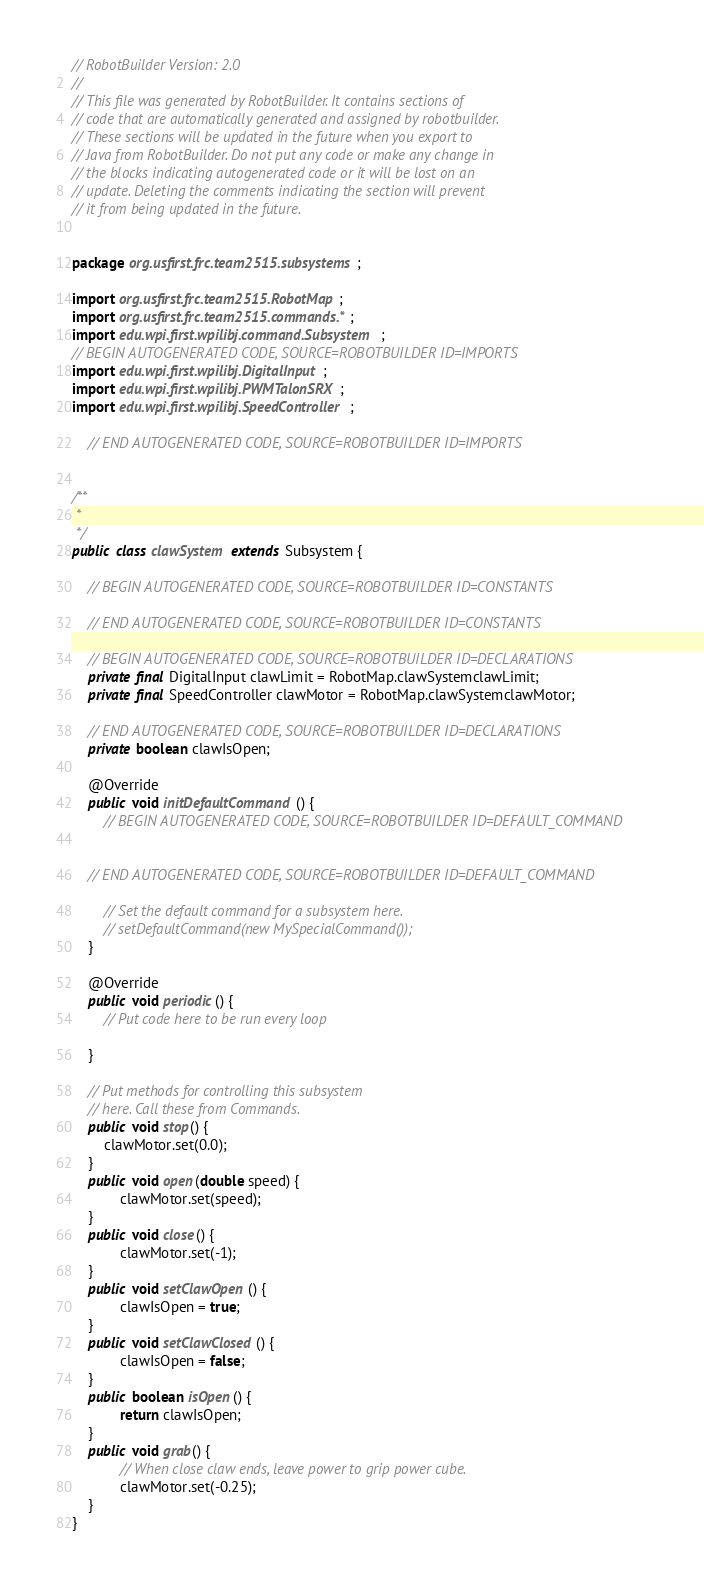<code> <loc_0><loc_0><loc_500><loc_500><_Java_>// RobotBuilder Version: 2.0
//
// This file was generated by RobotBuilder. It contains sections of
// code that are automatically generated and assigned by robotbuilder.
// These sections will be updated in the future when you export to
// Java from RobotBuilder. Do not put any code or make any change in
// the blocks indicating autogenerated code or it will be lost on an
// update. Deleting the comments indicating the section will prevent
// it from being updated in the future.


package org.usfirst.frc.team2515.subsystems;

import org.usfirst.frc.team2515.RobotMap;
import org.usfirst.frc.team2515.commands.*;
import edu.wpi.first.wpilibj.command.Subsystem;
// BEGIN AUTOGENERATED CODE, SOURCE=ROBOTBUILDER ID=IMPORTS
import edu.wpi.first.wpilibj.DigitalInput;
import edu.wpi.first.wpilibj.PWMTalonSRX;
import edu.wpi.first.wpilibj.SpeedController;

    // END AUTOGENERATED CODE, SOURCE=ROBOTBUILDER ID=IMPORTS


/**
 *
 */
public class clawSystem extends Subsystem {

    // BEGIN AUTOGENERATED CODE, SOURCE=ROBOTBUILDER ID=CONSTANTS

    // END AUTOGENERATED CODE, SOURCE=ROBOTBUILDER ID=CONSTANTS

    // BEGIN AUTOGENERATED CODE, SOURCE=ROBOTBUILDER ID=DECLARATIONS
    private final DigitalInput clawLimit = RobotMap.clawSystemclawLimit;
    private final SpeedController clawMotor = RobotMap.clawSystemclawMotor;

    // END AUTOGENERATED CODE, SOURCE=ROBOTBUILDER ID=DECLARATIONS
    private boolean clawIsOpen;
    
    @Override
    public void initDefaultCommand() {
        // BEGIN AUTOGENERATED CODE, SOURCE=ROBOTBUILDER ID=DEFAULT_COMMAND


    // END AUTOGENERATED CODE, SOURCE=ROBOTBUILDER ID=DEFAULT_COMMAND

        // Set the default command for a subsystem here.
        // setDefaultCommand(new MySpecialCommand());
    }

    @Override
    public void periodic() {
        // Put code here to be run every loop

    }

    // Put methods for controlling this subsystem
    // here. Call these from Commands.
    public void stop() {    			
		clawMotor.set(0.0);
    }
    public void open(double speed) {
    		clawMotor.set(speed);
    }
    public void close() {
    		clawMotor.set(-1);
    }
    public void setClawOpen() {
    		clawIsOpen = true;
    }
    public void setClawClosed() {
    		clawIsOpen = false;
    }
    public boolean isOpen() {
    		return clawIsOpen;
    }
    public void grab() {
    		// When close claw ends, leave power to grip power cube.
    		clawMotor.set(-0.25);
    }
}

</code> 